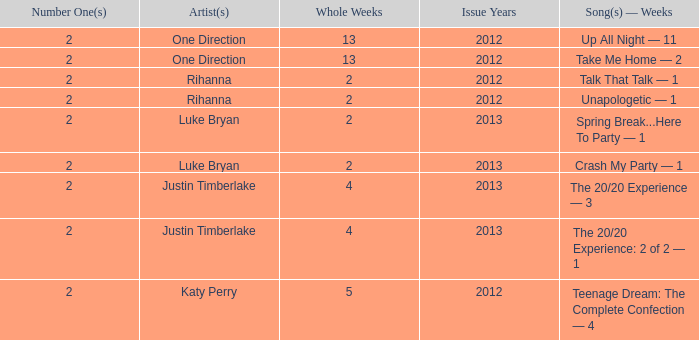What is the longest number of weeks any 1 song was at number #1? 13.0. 